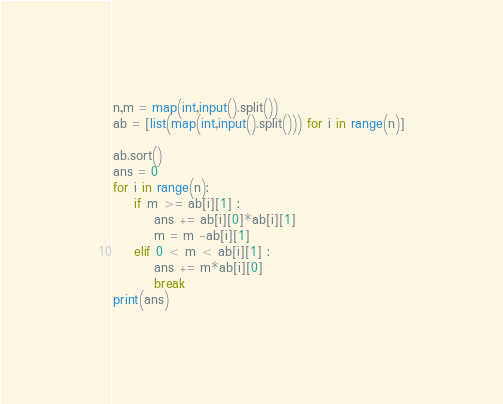Convert code to text. <code><loc_0><loc_0><loc_500><loc_500><_Python_>n,m = map(int,input().split())
ab = [list(map(int,input().split())) for i in range(n)]

ab.sort()
ans = 0
for i in range(n):
    if m >= ab[i][1] :
        ans += ab[i][0]*ab[i][1]
        m = m -ab[i][1]
    elif 0 < m < ab[i][1] :
        ans += m*ab[i][0]
        break
print(ans)
</code> 